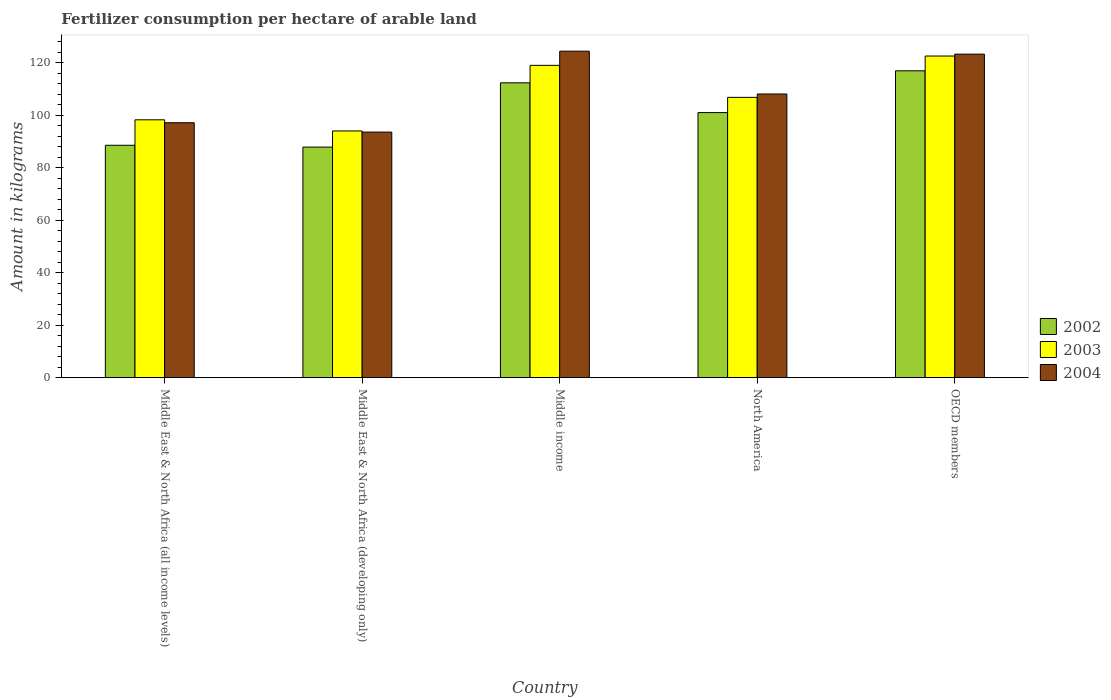Are the number of bars per tick equal to the number of legend labels?
Give a very brief answer. Yes. Are the number of bars on each tick of the X-axis equal?
Your answer should be very brief. Yes. How many bars are there on the 2nd tick from the left?
Ensure brevity in your answer.  3. What is the amount of fertilizer consumption in 2004 in OECD members?
Your response must be concise. 123.32. Across all countries, what is the maximum amount of fertilizer consumption in 2003?
Provide a succinct answer. 122.59. Across all countries, what is the minimum amount of fertilizer consumption in 2004?
Your response must be concise. 93.61. In which country was the amount of fertilizer consumption in 2002 maximum?
Offer a terse response. OECD members. In which country was the amount of fertilizer consumption in 2003 minimum?
Ensure brevity in your answer.  Middle East & North Africa (developing only). What is the total amount of fertilizer consumption in 2002 in the graph?
Provide a short and direct response. 506.85. What is the difference between the amount of fertilizer consumption in 2004 in Middle East & North Africa (all income levels) and that in North America?
Ensure brevity in your answer.  -10.95. What is the difference between the amount of fertilizer consumption in 2003 in Middle East & North Africa (all income levels) and the amount of fertilizer consumption in 2004 in OECD members?
Offer a very short reply. -25.04. What is the average amount of fertilizer consumption in 2003 per country?
Ensure brevity in your answer.  108.16. What is the difference between the amount of fertilizer consumption of/in 2002 and amount of fertilizer consumption of/in 2003 in Middle East & North Africa (developing only)?
Give a very brief answer. -6.15. What is the ratio of the amount of fertilizer consumption in 2003 in North America to that in OECD members?
Ensure brevity in your answer.  0.87. Is the difference between the amount of fertilizer consumption in 2002 in Middle East & North Africa (developing only) and Middle income greater than the difference between the amount of fertilizer consumption in 2003 in Middle East & North Africa (developing only) and Middle income?
Provide a succinct answer. Yes. What is the difference between the highest and the second highest amount of fertilizer consumption in 2003?
Offer a very short reply. 15.75. What is the difference between the highest and the lowest amount of fertilizer consumption in 2003?
Provide a short and direct response. 28.55. In how many countries, is the amount of fertilizer consumption in 2003 greater than the average amount of fertilizer consumption in 2003 taken over all countries?
Your response must be concise. 2. What does the 1st bar from the left in OECD members represents?
Provide a succinct answer. 2002. Is it the case that in every country, the sum of the amount of fertilizer consumption in 2004 and amount of fertilizer consumption in 2003 is greater than the amount of fertilizer consumption in 2002?
Provide a succinct answer. Yes. How many countries are there in the graph?
Keep it short and to the point. 5. Does the graph contain any zero values?
Give a very brief answer. No. How are the legend labels stacked?
Keep it short and to the point. Vertical. What is the title of the graph?
Give a very brief answer. Fertilizer consumption per hectare of arable land. Does "1964" appear as one of the legend labels in the graph?
Your answer should be very brief. No. What is the label or title of the X-axis?
Provide a succinct answer. Country. What is the label or title of the Y-axis?
Provide a succinct answer. Amount in kilograms. What is the Amount in kilograms in 2002 in Middle East & North Africa (all income levels)?
Make the answer very short. 88.58. What is the Amount in kilograms of 2003 in Middle East & North Africa (all income levels)?
Give a very brief answer. 98.29. What is the Amount in kilograms in 2004 in Middle East & North Africa (all income levels)?
Provide a short and direct response. 97.18. What is the Amount in kilograms of 2002 in Middle East & North Africa (developing only)?
Your response must be concise. 87.88. What is the Amount in kilograms in 2003 in Middle East & North Africa (developing only)?
Ensure brevity in your answer.  94.04. What is the Amount in kilograms in 2004 in Middle East & North Africa (developing only)?
Your response must be concise. 93.61. What is the Amount in kilograms of 2002 in Middle income?
Keep it short and to the point. 112.38. What is the Amount in kilograms in 2003 in Middle income?
Keep it short and to the point. 119.04. What is the Amount in kilograms in 2004 in Middle income?
Your response must be concise. 124.44. What is the Amount in kilograms in 2002 in North America?
Provide a succinct answer. 101.04. What is the Amount in kilograms in 2003 in North America?
Keep it short and to the point. 106.84. What is the Amount in kilograms of 2004 in North America?
Provide a succinct answer. 108.13. What is the Amount in kilograms of 2002 in OECD members?
Give a very brief answer. 116.96. What is the Amount in kilograms in 2003 in OECD members?
Offer a terse response. 122.59. What is the Amount in kilograms in 2004 in OECD members?
Offer a terse response. 123.32. Across all countries, what is the maximum Amount in kilograms of 2002?
Ensure brevity in your answer.  116.96. Across all countries, what is the maximum Amount in kilograms of 2003?
Provide a succinct answer. 122.59. Across all countries, what is the maximum Amount in kilograms in 2004?
Make the answer very short. 124.44. Across all countries, what is the minimum Amount in kilograms of 2002?
Offer a very short reply. 87.88. Across all countries, what is the minimum Amount in kilograms of 2003?
Provide a succinct answer. 94.04. Across all countries, what is the minimum Amount in kilograms of 2004?
Your response must be concise. 93.61. What is the total Amount in kilograms of 2002 in the graph?
Make the answer very short. 506.85. What is the total Amount in kilograms of 2003 in the graph?
Your answer should be compact. 540.79. What is the total Amount in kilograms in 2004 in the graph?
Ensure brevity in your answer.  546.67. What is the difference between the Amount in kilograms in 2002 in Middle East & North Africa (all income levels) and that in Middle East & North Africa (developing only)?
Your response must be concise. 0.69. What is the difference between the Amount in kilograms in 2003 in Middle East & North Africa (all income levels) and that in Middle East & North Africa (developing only)?
Your answer should be very brief. 4.25. What is the difference between the Amount in kilograms in 2004 in Middle East & North Africa (all income levels) and that in Middle East & North Africa (developing only)?
Your answer should be compact. 3.57. What is the difference between the Amount in kilograms of 2002 in Middle East & North Africa (all income levels) and that in Middle income?
Your answer should be compact. -23.81. What is the difference between the Amount in kilograms in 2003 in Middle East & North Africa (all income levels) and that in Middle income?
Ensure brevity in your answer.  -20.75. What is the difference between the Amount in kilograms in 2004 in Middle East & North Africa (all income levels) and that in Middle income?
Your response must be concise. -27.26. What is the difference between the Amount in kilograms in 2002 in Middle East & North Africa (all income levels) and that in North America?
Provide a short and direct response. -12.46. What is the difference between the Amount in kilograms of 2003 in Middle East & North Africa (all income levels) and that in North America?
Your answer should be compact. -8.55. What is the difference between the Amount in kilograms of 2004 in Middle East & North Africa (all income levels) and that in North America?
Offer a terse response. -10.95. What is the difference between the Amount in kilograms in 2002 in Middle East & North Africa (all income levels) and that in OECD members?
Your answer should be very brief. -28.38. What is the difference between the Amount in kilograms of 2003 in Middle East & North Africa (all income levels) and that in OECD members?
Provide a succinct answer. -24.3. What is the difference between the Amount in kilograms of 2004 in Middle East & North Africa (all income levels) and that in OECD members?
Make the answer very short. -26.15. What is the difference between the Amount in kilograms of 2002 in Middle East & North Africa (developing only) and that in Middle income?
Your answer should be very brief. -24.5. What is the difference between the Amount in kilograms of 2003 in Middle East & North Africa (developing only) and that in Middle income?
Your answer should be compact. -25. What is the difference between the Amount in kilograms in 2004 in Middle East & North Africa (developing only) and that in Middle income?
Provide a succinct answer. -30.83. What is the difference between the Amount in kilograms of 2002 in Middle East & North Africa (developing only) and that in North America?
Make the answer very short. -13.16. What is the difference between the Amount in kilograms of 2003 in Middle East & North Africa (developing only) and that in North America?
Ensure brevity in your answer.  -12.8. What is the difference between the Amount in kilograms of 2004 in Middle East & North Africa (developing only) and that in North America?
Keep it short and to the point. -14.52. What is the difference between the Amount in kilograms of 2002 in Middle East & North Africa (developing only) and that in OECD members?
Offer a very short reply. -29.08. What is the difference between the Amount in kilograms in 2003 in Middle East & North Africa (developing only) and that in OECD members?
Make the answer very short. -28.55. What is the difference between the Amount in kilograms of 2004 in Middle East & North Africa (developing only) and that in OECD members?
Your answer should be compact. -29.71. What is the difference between the Amount in kilograms in 2002 in Middle income and that in North America?
Provide a short and direct response. 11.34. What is the difference between the Amount in kilograms of 2003 in Middle income and that in North America?
Provide a succinct answer. 12.2. What is the difference between the Amount in kilograms in 2004 in Middle income and that in North America?
Your response must be concise. 16.31. What is the difference between the Amount in kilograms of 2002 in Middle income and that in OECD members?
Your answer should be very brief. -4.58. What is the difference between the Amount in kilograms in 2003 in Middle income and that in OECD members?
Give a very brief answer. -3.55. What is the difference between the Amount in kilograms in 2004 in Middle income and that in OECD members?
Ensure brevity in your answer.  1.12. What is the difference between the Amount in kilograms in 2002 in North America and that in OECD members?
Ensure brevity in your answer.  -15.92. What is the difference between the Amount in kilograms of 2003 in North America and that in OECD members?
Your response must be concise. -15.75. What is the difference between the Amount in kilograms of 2004 in North America and that in OECD members?
Offer a very short reply. -15.2. What is the difference between the Amount in kilograms of 2002 in Middle East & North Africa (all income levels) and the Amount in kilograms of 2003 in Middle East & North Africa (developing only)?
Give a very brief answer. -5.46. What is the difference between the Amount in kilograms in 2002 in Middle East & North Africa (all income levels) and the Amount in kilograms in 2004 in Middle East & North Africa (developing only)?
Keep it short and to the point. -5.03. What is the difference between the Amount in kilograms in 2003 in Middle East & North Africa (all income levels) and the Amount in kilograms in 2004 in Middle East & North Africa (developing only)?
Your answer should be very brief. 4.68. What is the difference between the Amount in kilograms in 2002 in Middle East & North Africa (all income levels) and the Amount in kilograms in 2003 in Middle income?
Give a very brief answer. -30.46. What is the difference between the Amount in kilograms of 2002 in Middle East & North Africa (all income levels) and the Amount in kilograms of 2004 in Middle income?
Provide a short and direct response. -35.86. What is the difference between the Amount in kilograms in 2003 in Middle East & North Africa (all income levels) and the Amount in kilograms in 2004 in Middle income?
Give a very brief answer. -26.15. What is the difference between the Amount in kilograms of 2002 in Middle East & North Africa (all income levels) and the Amount in kilograms of 2003 in North America?
Make the answer very short. -18.26. What is the difference between the Amount in kilograms of 2002 in Middle East & North Africa (all income levels) and the Amount in kilograms of 2004 in North America?
Ensure brevity in your answer.  -19.55. What is the difference between the Amount in kilograms in 2003 in Middle East & North Africa (all income levels) and the Amount in kilograms in 2004 in North America?
Your response must be concise. -9.84. What is the difference between the Amount in kilograms of 2002 in Middle East & North Africa (all income levels) and the Amount in kilograms of 2003 in OECD members?
Provide a short and direct response. -34.01. What is the difference between the Amount in kilograms of 2002 in Middle East & North Africa (all income levels) and the Amount in kilograms of 2004 in OECD members?
Make the answer very short. -34.74. What is the difference between the Amount in kilograms in 2003 in Middle East & North Africa (all income levels) and the Amount in kilograms in 2004 in OECD members?
Offer a terse response. -25.04. What is the difference between the Amount in kilograms of 2002 in Middle East & North Africa (developing only) and the Amount in kilograms of 2003 in Middle income?
Your response must be concise. -31.16. What is the difference between the Amount in kilograms of 2002 in Middle East & North Africa (developing only) and the Amount in kilograms of 2004 in Middle income?
Ensure brevity in your answer.  -36.55. What is the difference between the Amount in kilograms in 2003 in Middle East & North Africa (developing only) and the Amount in kilograms in 2004 in Middle income?
Provide a short and direct response. -30.4. What is the difference between the Amount in kilograms of 2002 in Middle East & North Africa (developing only) and the Amount in kilograms of 2003 in North America?
Ensure brevity in your answer.  -18.95. What is the difference between the Amount in kilograms in 2002 in Middle East & North Africa (developing only) and the Amount in kilograms in 2004 in North America?
Provide a short and direct response. -20.24. What is the difference between the Amount in kilograms of 2003 in Middle East & North Africa (developing only) and the Amount in kilograms of 2004 in North America?
Make the answer very short. -14.09. What is the difference between the Amount in kilograms in 2002 in Middle East & North Africa (developing only) and the Amount in kilograms in 2003 in OECD members?
Offer a terse response. -34.71. What is the difference between the Amount in kilograms of 2002 in Middle East & North Africa (developing only) and the Amount in kilograms of 2004 in OECD members?
Offer a very short reply. -35.44. What is the difference between the Amount in kilograms in 2003 in Middle East & North Africa (developing only) and the Amount in kilograms in 2004 in OECD members?
Offer a very short reply. -29.29. What is the difference between the Amount in kilograms of 2002 in Middle income and the Amount in kilograms of 2003 in North America?
Ensure brevity in your answer.  5.54. What is the difference between the Amount in kilograms in 2002 in Middle income and the Amount in kilograms in 2004 in North America?
Offer a terse response. 4.26. What is the difference between the Amount in kilograms in 2003 in Middle income and the Amount in kilograms in 2004 in North America?
Your answer should be very brief. 10.91. What is the difference between the Amount in kilograms in 2002 in Middle income and the Amount in kilograms in 2003 in OECD members?
Keep it short and to the point. -10.21. What is the difference between the Amount in kilograms of 2002 in Middle income and the Amount in kilograms of 2004 in OECD members?
Ensure brevity in your answer.  -10.94. What is the difference between the Amount in kilograms in 2003 in Middle income and the Amount in kilograms in 2004 in OECD members?
Offer a very short reply. -4.28. What is the difference between the Amount in kilograms in 2002 in North America and the Amount in kilograms in 2003 in OECD members?
Provide a succinct answer. -21.55. What is the difference between the Amount in kilograms of 2002 in North America and the Amount in kilograms of 2004 in OECD members?
Make the answer very short. -22.28. What is the difference between the Amount in kilograms of 2003 in North America and the Amount in kilograms of 2004 in OECD members?
Make the answer very short. -16.48. What is the average Amount in kilograms in 2002 per country?
Give a very brief answer. 101.37. What is the average Amount in kilograms in 2003 per country?
Give a very brief answer. 108.16. What is the average Amount in kilograms in 2004 per country?
Keep it short and to the point. 109.33. What is the difference between the Amount in kilograms in 2002 and Amount in kilograms in 2003 in Middle East & North Africa (all income levels)?
Your response must be concise. -9.71. What is the difference between the Amount in kilograms of 2002 and Amount in kilograms of 2004 in Middle East & North Africa (all income levels)?
Your answer should be compact. -8.6. What is the difference between the Amount in kilograms in 2002 and Amount in kilograms in 2003 in Middle East & North Africa (developing only)?
Keep it short and to the point. -6.15. What is the difference between the Amount in kilograms of 2002 and Amount in kilograms of 2004 in Middle East & North Africa (developing only)?
Your answer should be very brief. -5.72. What is the difference between the Amount in kilograms of 2003 and Amount in kilograms of 2004 in Middle East & North Africa (developing only)?
Give a very brief answer. 0.43. What is the difference between the Amount in kilograms of 2002 and Amount in kilograms of 2003 in Middle income?
Provide a succinct answer. -6.66. What is the difference between the Amount in kilograms in 2002 and Amount in kilograms in 2004 in Middle income?
Give a very brief answer. -12.05. What is the difference between the Amount in kilograms of 2003 and Amount in kilograms of 2004 in Middle income?
Your answer should be very brief. -5.4. What is the difference between the Amount in kilograms of 2002 and Amount in kilograms of 2003 in North America?
Keep it short and to the point. -5.8. What is the difference between the Amount in kilograms in 2002 and Amount in kilograms in 2004 in North America?
Offer a very short reply. -7.09. What is the difference between the Amount in kilograms of 2003 and Amount in kilograms of 2004 in North America?
Ensure brevity in your answer.  -1.29. What is the difference between the Amount in kilograms of 2002 and Amount in kilograms of 2003 in OECD members?
Offer a terse response. -5.63. What is the difference between the Amount in kilograms in 2002 and Amount in kilograms in 2004 in OECD members?
Your answer should be very brief. -6.36. What is the difference between the Amount in kilograms of 2003 and Amount in kilograms of 2004 in OECD members?
Your response must be concise. -0.73. What is the ratio of the Amount in kilograms of 2002 in Middle East & North Africa (all income levels) to that in Middle East & North Africa (developing only)?
Give a very brief answer. 1.01. What is the ratio of the Amount in kilograms of 2003 in Middle East & North Africa (all income levels) to that in Middle East & North Africa (developing only)?
Give a very brief answer. 1.05. What is the ratio of the Amount in kilograms in 2004 in Middle East & North Africa (all income levels) to that in Middle East & North Africa (developing only)?
Offer a very short reply. 1.04. What is the ratio of the Amount in kilograms of 2002 in Middle East & North Africa (all income levels) to that in Middle income?
Your answer should be very brief. 0.79. What is the ratio of the Amount in kilograms of 2003 in Middle East & North Africa (all income levels) to that in Middle income?
Make the answer very short. 0.83. What is the ratio of the Amount in kilograms of 2004 in Middle East & North Africa (all income levels) to that in Middle income?
Make the answer very short. 0.78. What is the ratio of the Amount in kilograms in 2002 in Middle East & North Africa (all income levels) to that in North America?
Offer a very short reply. 0.88. What is the ratio of the Amount in kilograms of 2004 in Middle East & North Africa (all income levels) to that in North America?
Provide a short and direct response. 0.9. What is the ratio of the Amount in kilograms of 2002 in Middle East & North Africa (all income levels) to that in OECD members?
Keep it short and to the point. 0.76. What is the ratio of the Amount in kilograms in 2003 in Middle East & North Africa (all income levels) to that in OECD members?
Ensure brevity in your answer.  0.8. What is the ratio of the Amount in kilograms of 2004 in Middle East & North Africa (all income levels) to that in OECD members?
Provide a succinct answer. 0.79. What is the ratio of the Amount in kilograms in 2002 in Middle East & North Africa (developing only) to that in Middle income?
Provide a succinct answer. 0.78. What is the ratio of the Amount in kilograms of 2003 in Middle East & North Africa (developing only) to that in Middle income?
Give a very brief answer. 0.79. What is the ratio of the Amount in kilograms in 2004 in Middle East & North Africa (developing only) to that in Middle income?
Ensure brevity in your answer.  0.75. What is the ratio of the Amount in kilograms of 2002 in Middle East & North Africa (developing only) to that in North America?
Ensure brevity in your answer.  0.87. What is the ratio of the Amount in kilograms of 2003 in Middle East & North Africa (developing only) to that in North America?
Give a very brief answer. 0.88. What is the ratio of the Amount in kilograms in 2004 in Middle East & North Africa (developing only) to that in North America?
Offer a very short reply. 0.87. What is the ratio of the Amount in kilograms in 2002 in Middle East & North Africa (developing only) to that in OECD members?
Keep it short and to the point. 0.75. What is the ratio of the Amount in kilograms of 2003 in Middle East & North Africa (developing only) to that in OECD members?
Keep it short and to the point. 0.77. What is the ratio of the Amount in kilograms of 2004 in Middle East & North Africa (developing only) to that in OECD members?
Give a very brief answer. 0.76. What is the ratio of the Amount in kilograms of 2002 in Middle income to that in North America?
Provide a short and direct response. 1.11. What is the ratio of the Amount in kilograms in 2003 in Middle income to that in North America?
Keep it short and to the point. 1.11. What is the ratio of the Amount in kilograms of 2004 in Middle income to that in North America?
Keep it short and to the point. 1.15. What is the ratio of the Amount in kilograms in 2002 in Middle income to that in OECD members?
Your response must be concise. 0.96. What is the ratio of the Amount in kilograms in 2003 in Middle income to that in OECD members?
Your answer should be compact. 0.97. What is the ratio of the Amount in kilograms in 2004 in Middle income to that in OECD members?
Ensure brevity in your answer.  1.01. What is the ratio of the Amount in kilograms of 2002 in North America to that in OECD members?
Your response must be concise. 0.86. What is the ratio of the Amount in kilograms in 2003 in North America to that in OECD members?
Your answer should be very brief. 0.87. What is the ratio of the Amount in kilograms in 2004 in North America to that in OECD members?
Your answer should be very brief. 0.88. What is the difference between the highest and the second highest Amount in kilograms of 2002?
Provide a succinct answer. 4.58. What is the difference between the highest and the second highest Amount in kilograms of 2003?
Give a very brief answer. 3.55. What is the difference between the highest and the second highest Amount in kilograms of 2004?
Give a very brief answer. 1.12. What is the difference between the highest and the lowest Amount in kilograms in 2002?
Your response must be concise. 29.08. What is the difference between the highest and the lowest Amount in kilograms in 2003?
Your answer should be compact. 28.55. What is the difference between the highest and the lowest Amount in kilograms of 2004?
Offer a very short reply. 30.83. 